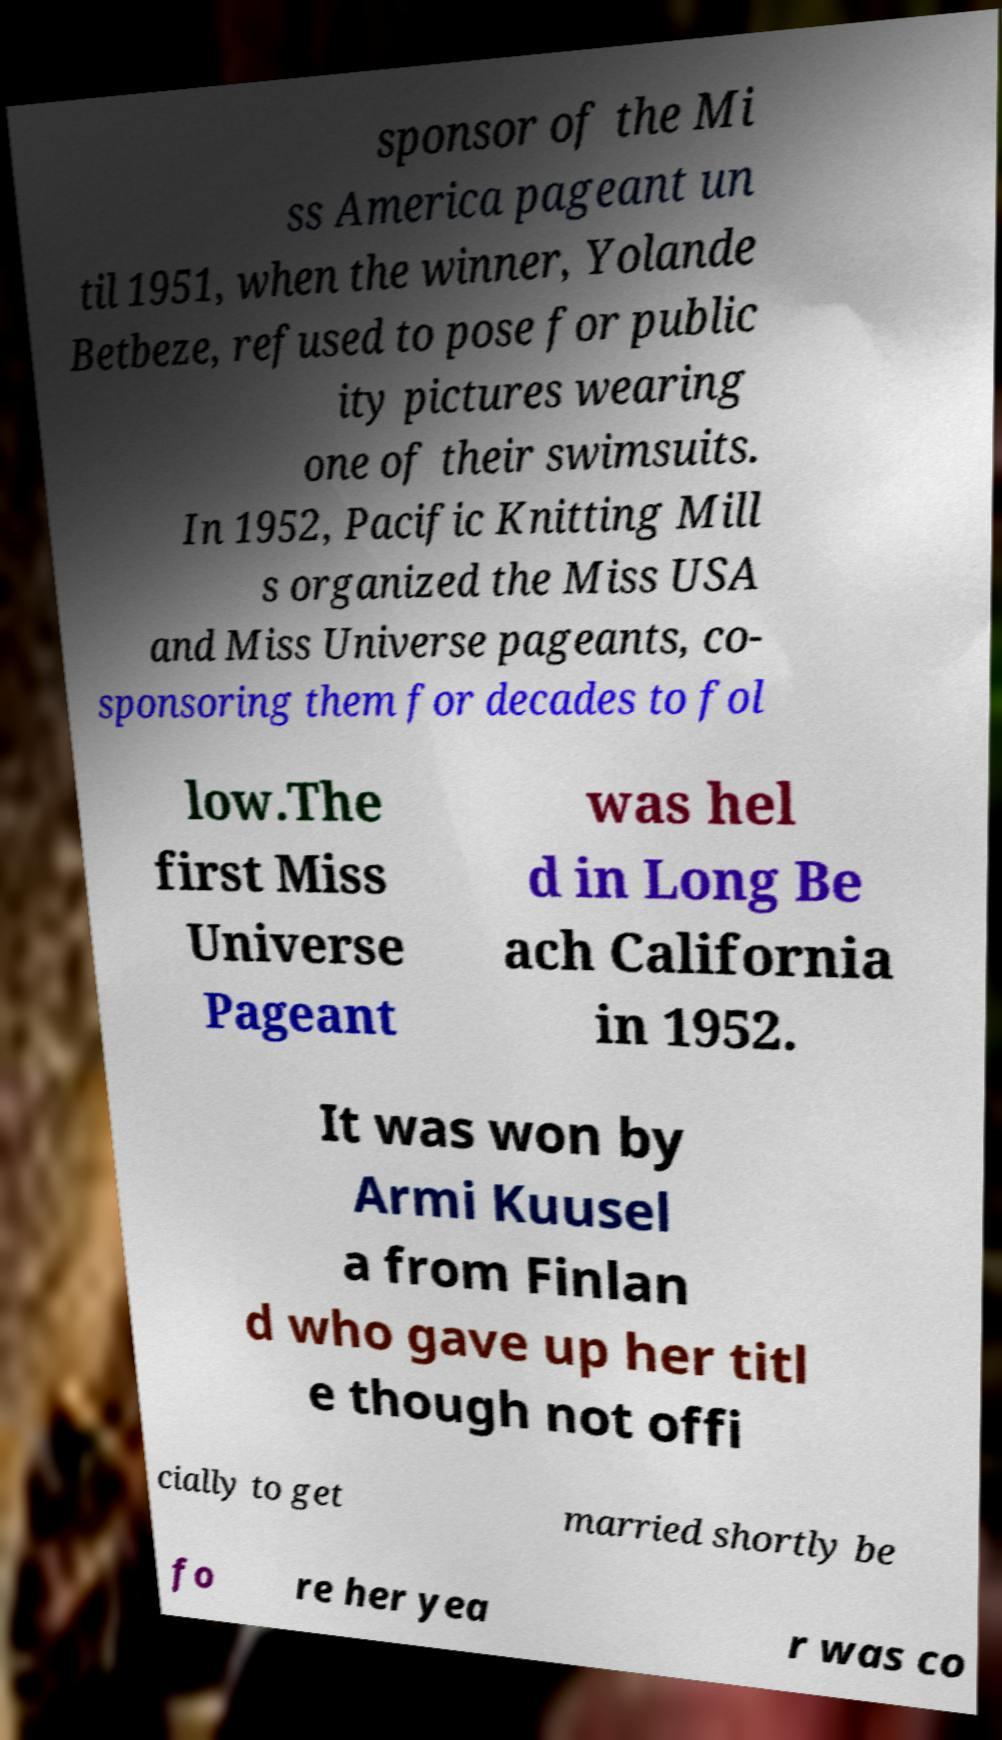Please read and relay the text visible in this image. What does it say? sponsor of the Mi ss America pageant un til 1951, when the winner, Yolande Betbeze, refused to pose for public ity pictures wearing one of their swimsuits. In 1952, Pacific Knitting Mill s organized the Miss USA and Miss Universe pageants, co- sponsoring them for decades to fol low.The first Miss Universe Pageant was hel d in Long Be ach California in 1952. It was won by Armi Kuusel a from Finlan d who gave up her titl e though not offi cially to get married shortly be fo re her yea r was co 